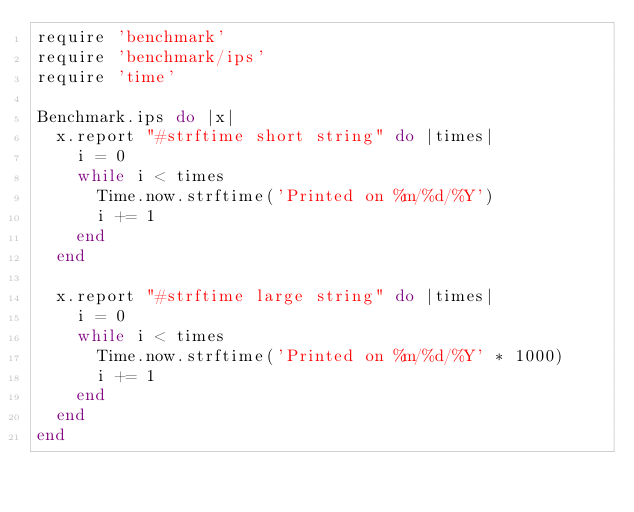Convert code to text. <code><loc_0><loc_0><loc_500><loc_500><_Ruby_>require 'benchmark'
require 'benchmark/ips'
require 'time'

Benchmark.ips do |x|
  x.report "#strftime short string" do |times|
    i = 0
    while i < times
      Time.now.strftime('Printed on %m/%d/%Y')
      i += 1
    end
  end

  x.report "#strftime large string" do |times|
    i = 0
    while i < times
      Time.now.strftime('Printed on %m/%d/%Y' * 1000)
      i += 1
    end
  end
end
</code> 